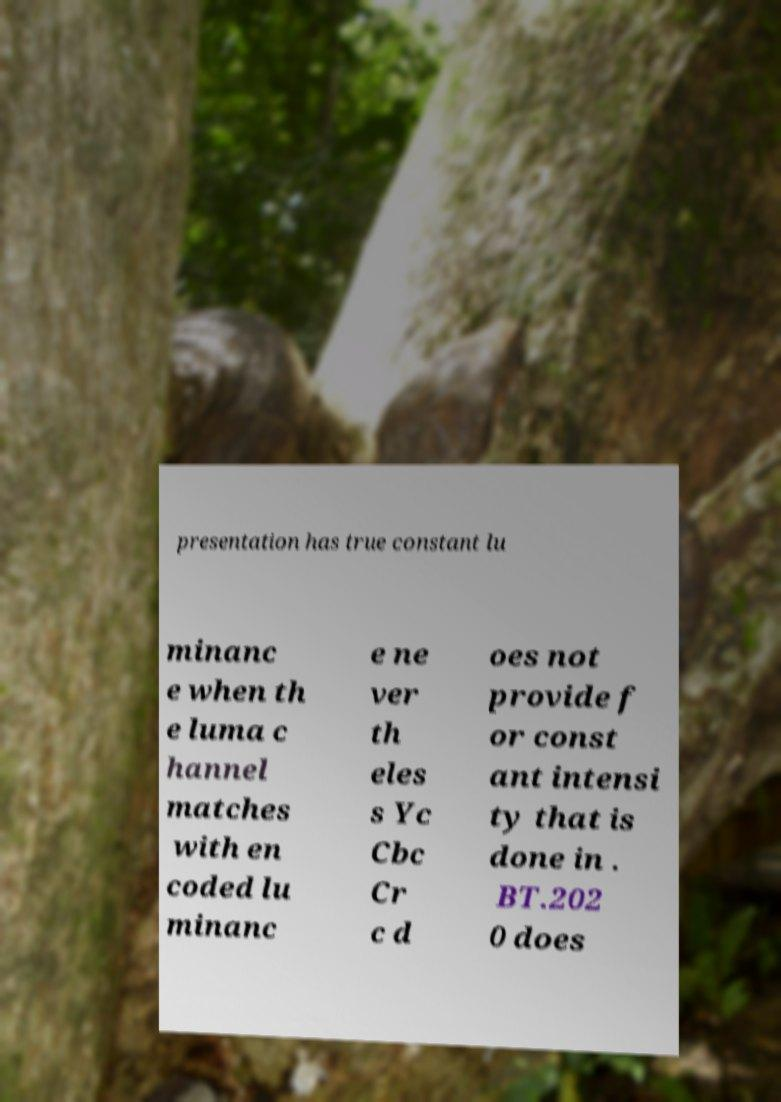Please read and relay the text visible in this image. What does it say? presentation has true constant lu minanc e when th e luma c hannel matches with en coded lu minanc e ne ver th eles s Yc Cbc Cr c d oes not provide f or const ant intensi ty that is done in . BT.202 0 does 